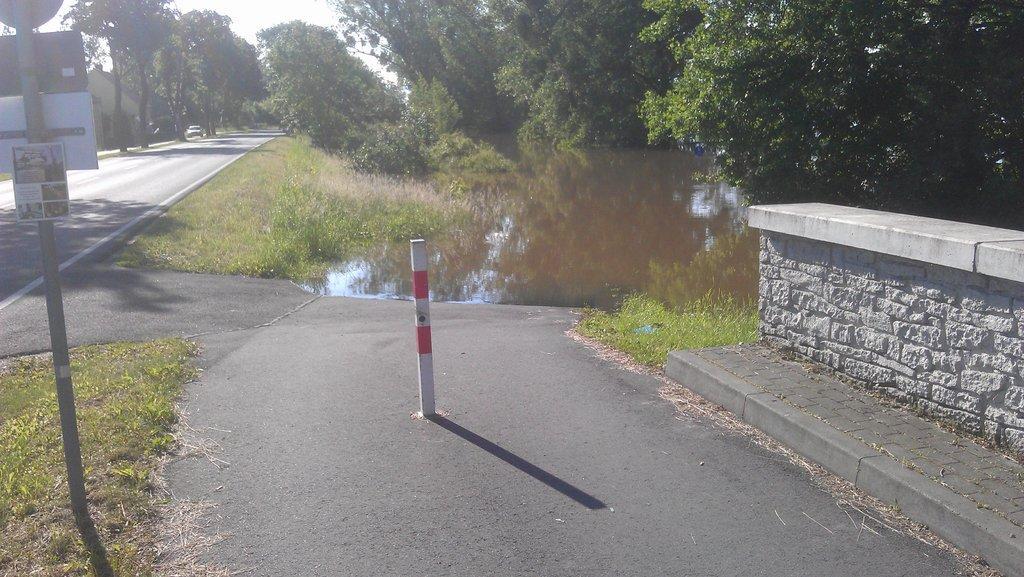In one or two sentences, can you explain what this image depicts? On the left side there is a board, on that board there is some text and there is a road, on that road there is a car and there is a path, on the right side there is a small wall, in the background there is a canal and there are trees. 